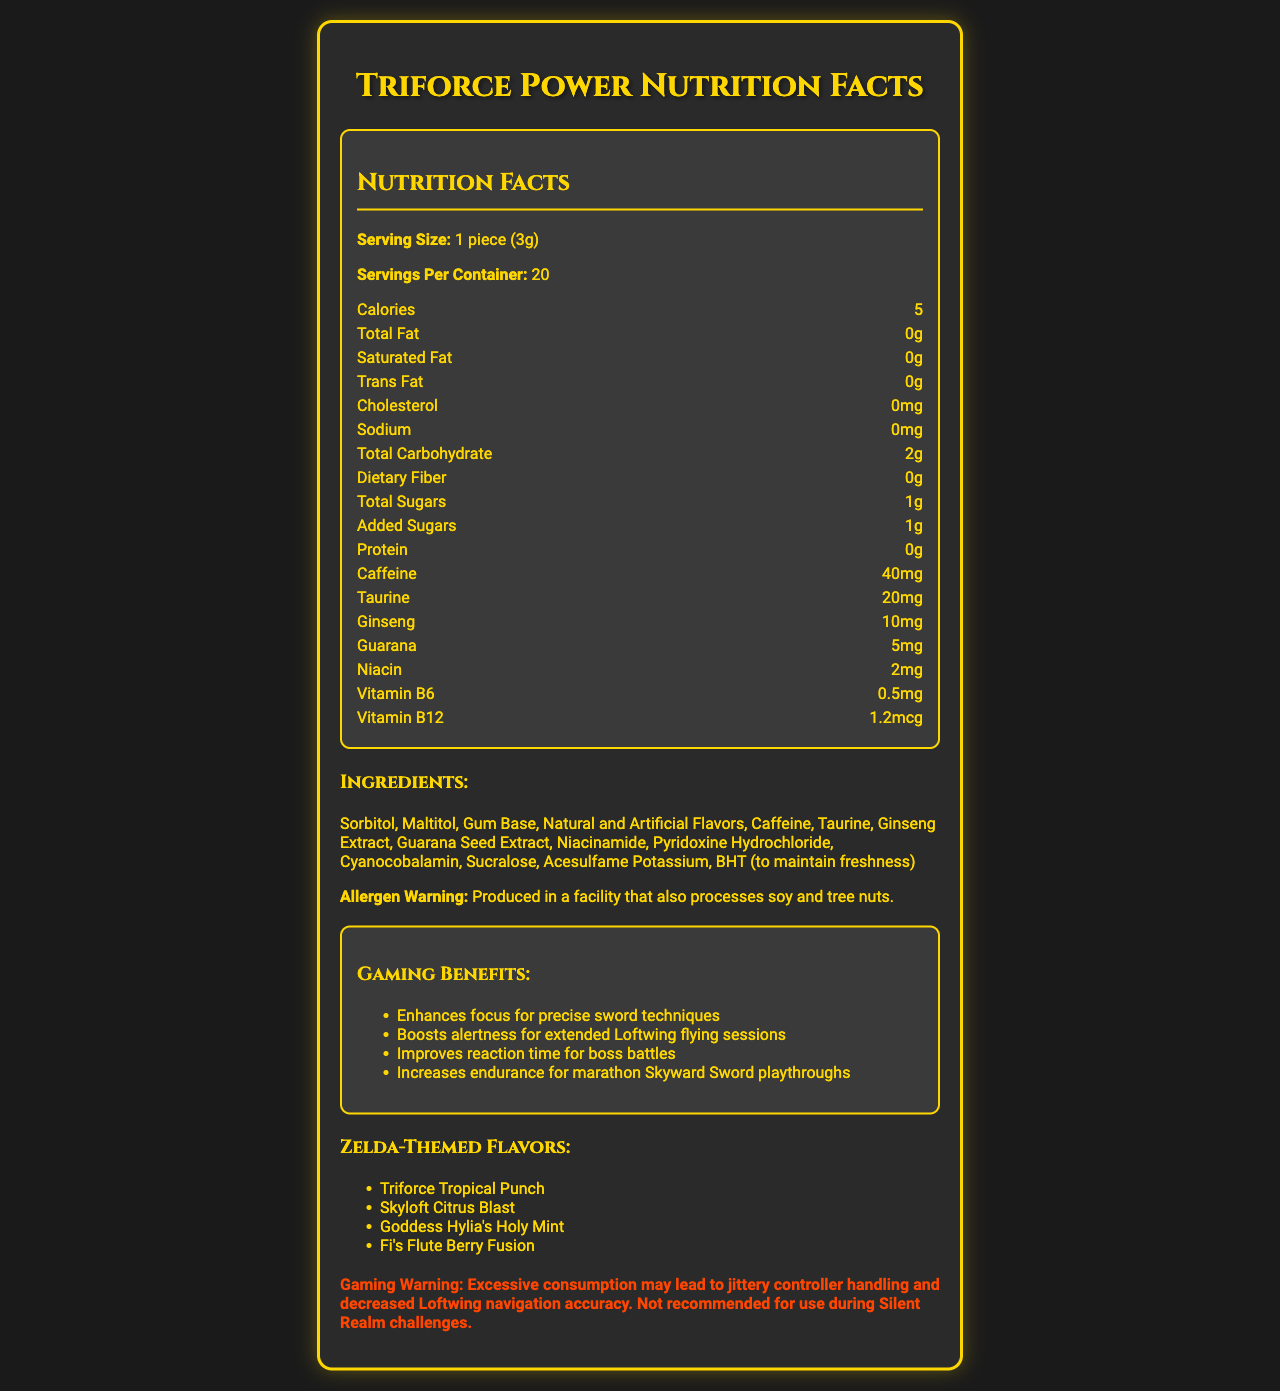what is the serving size for Triforce Power gum? The serving size is directly mentioned in the document under the "Nutrition Facts" section.
Answer: 1 piece (3g) how many calories are in one serving of Triforce Power gum? The calories per serving are listed as 5 in the "Nutrition Facts" section.
Answer: 5 what is the added sugar content in one piece of Triforce Power gum? The added sugar content is displayed as 1g in the "Nutrition Facts" section.
Answer: 1g how many pieces are there per container? The document states that there are 20 servings per container, and since the serving size is 1 piece, this means there are 20 pieces per container.
Answer: 20 how much caffeine is in one piece of the gum? The caffeine content per piece is shown as 40mg in the "Nutrition Facts" section.
Answer: 40mg which of the following is a Zelda-themed flavor of the gum? A. Triforce Tropical Punch B. Darknut Dark Chocolate C. Lon Lon Milk Latte D. Ganondorf's Ginger Spice The available Zelda-themed flavors listed in the document are "Triforce Tropical Punch", "Skyloft Citrus Blast", "Goddess Hylia's Holy Mint", and "Fi's Flute Berry Fusion". "Triforce Tropical Punch" is one of them.
Answer: A which ingredient is not listed in the content of Triforce Power gum? A. Sorbitol B. Maltitol C. Aspartame D. Sucralose The ingredients list includes Sorbitol, Maltitol, Gum Base, Natural and Artificial Flavors, Caffeine, Taurine, Ginseng Extract, Guarana Seed Extract, Niacinamide, Pyridoxine Hydrochloride, Cyanocobalamin, Sucralose, and Acesulfame Potassium, but not Aspartame.
Answer: C is Triforce Power gum safe for someone with a tree nut allergy? The allergen warning states that the product is produced in a facility that also processes soy and tree nuts.
Answer: No summarize the document. The document offers comprehensive details about the gum, from nutritional facts to ingredients and specific gaming benefits and warnings, aimed at gamers, particularly fans of The Legend of Zelda series.
Answer: The document provides detailed nutritional information for "Triforce Power" caffeinated chewing gum, which includes serving size, calories, various nutrients, and ingredients. It highlights Zelda-themed flavors and lists gaming benefits such as enhanced focus and alertness. There are warnings regarding allergen processing and potential side effects from excessive consumption. how much protein does one piece of the gum contain? The protein content is listed as 0g in the "Nutrition Facts" section.
Answer: 0g identify one gaming benefit associated with consuming Triforce Power gum. One of the gaming benefits listed is "Enhances focus for precise sword techniques."
Answer: Enhances focus for precise sword techniques what is the sodium content in a single serving of Triforce Power gum? The sodium content per serving is listed as 0mg in the "Nutrition Facts" section.
Answer: 0mg how much niacin does one piece of the gum contain? The niacin content is listed as 2mg per piece in the "Nutrition Facts" section.
Answer: 2mg can the exact manufacturing location of the gum be determined from the document? The document does not provide the exact manufacturing location of the gum.
Answer: Cannot be determined is excessive consumption of the gum recommended during Silent Realm challenges? The gaming warning specifically states that excessive consumption is not recommended during Silent Realm challenges.
Answer: No 